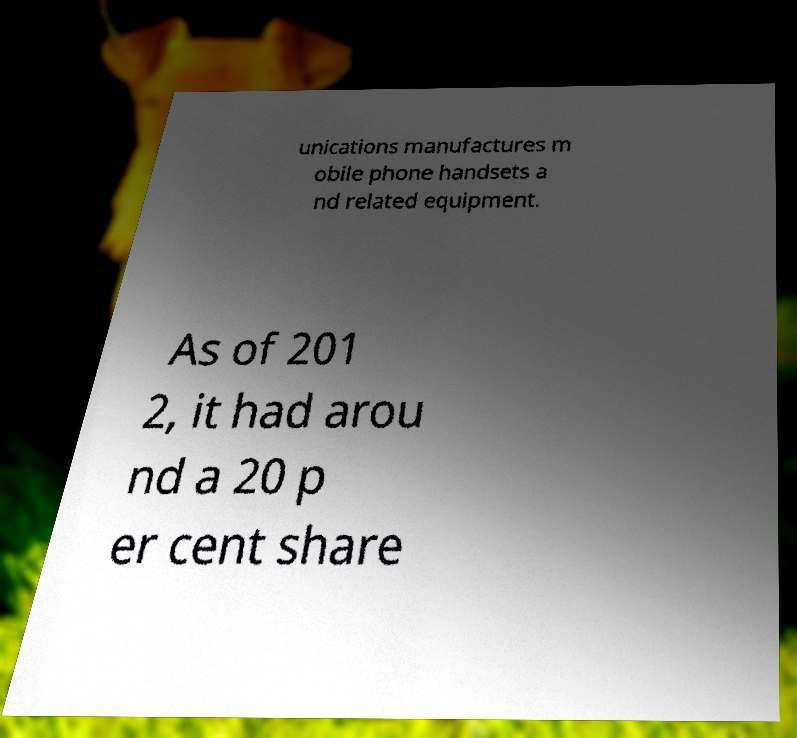What messages or text are displayed in this image? I need them in a readable, typed format. unications manufactures m obile phone handsets a nd related equipment. As of 201 2, it had arou nd a 20 p er cent share 